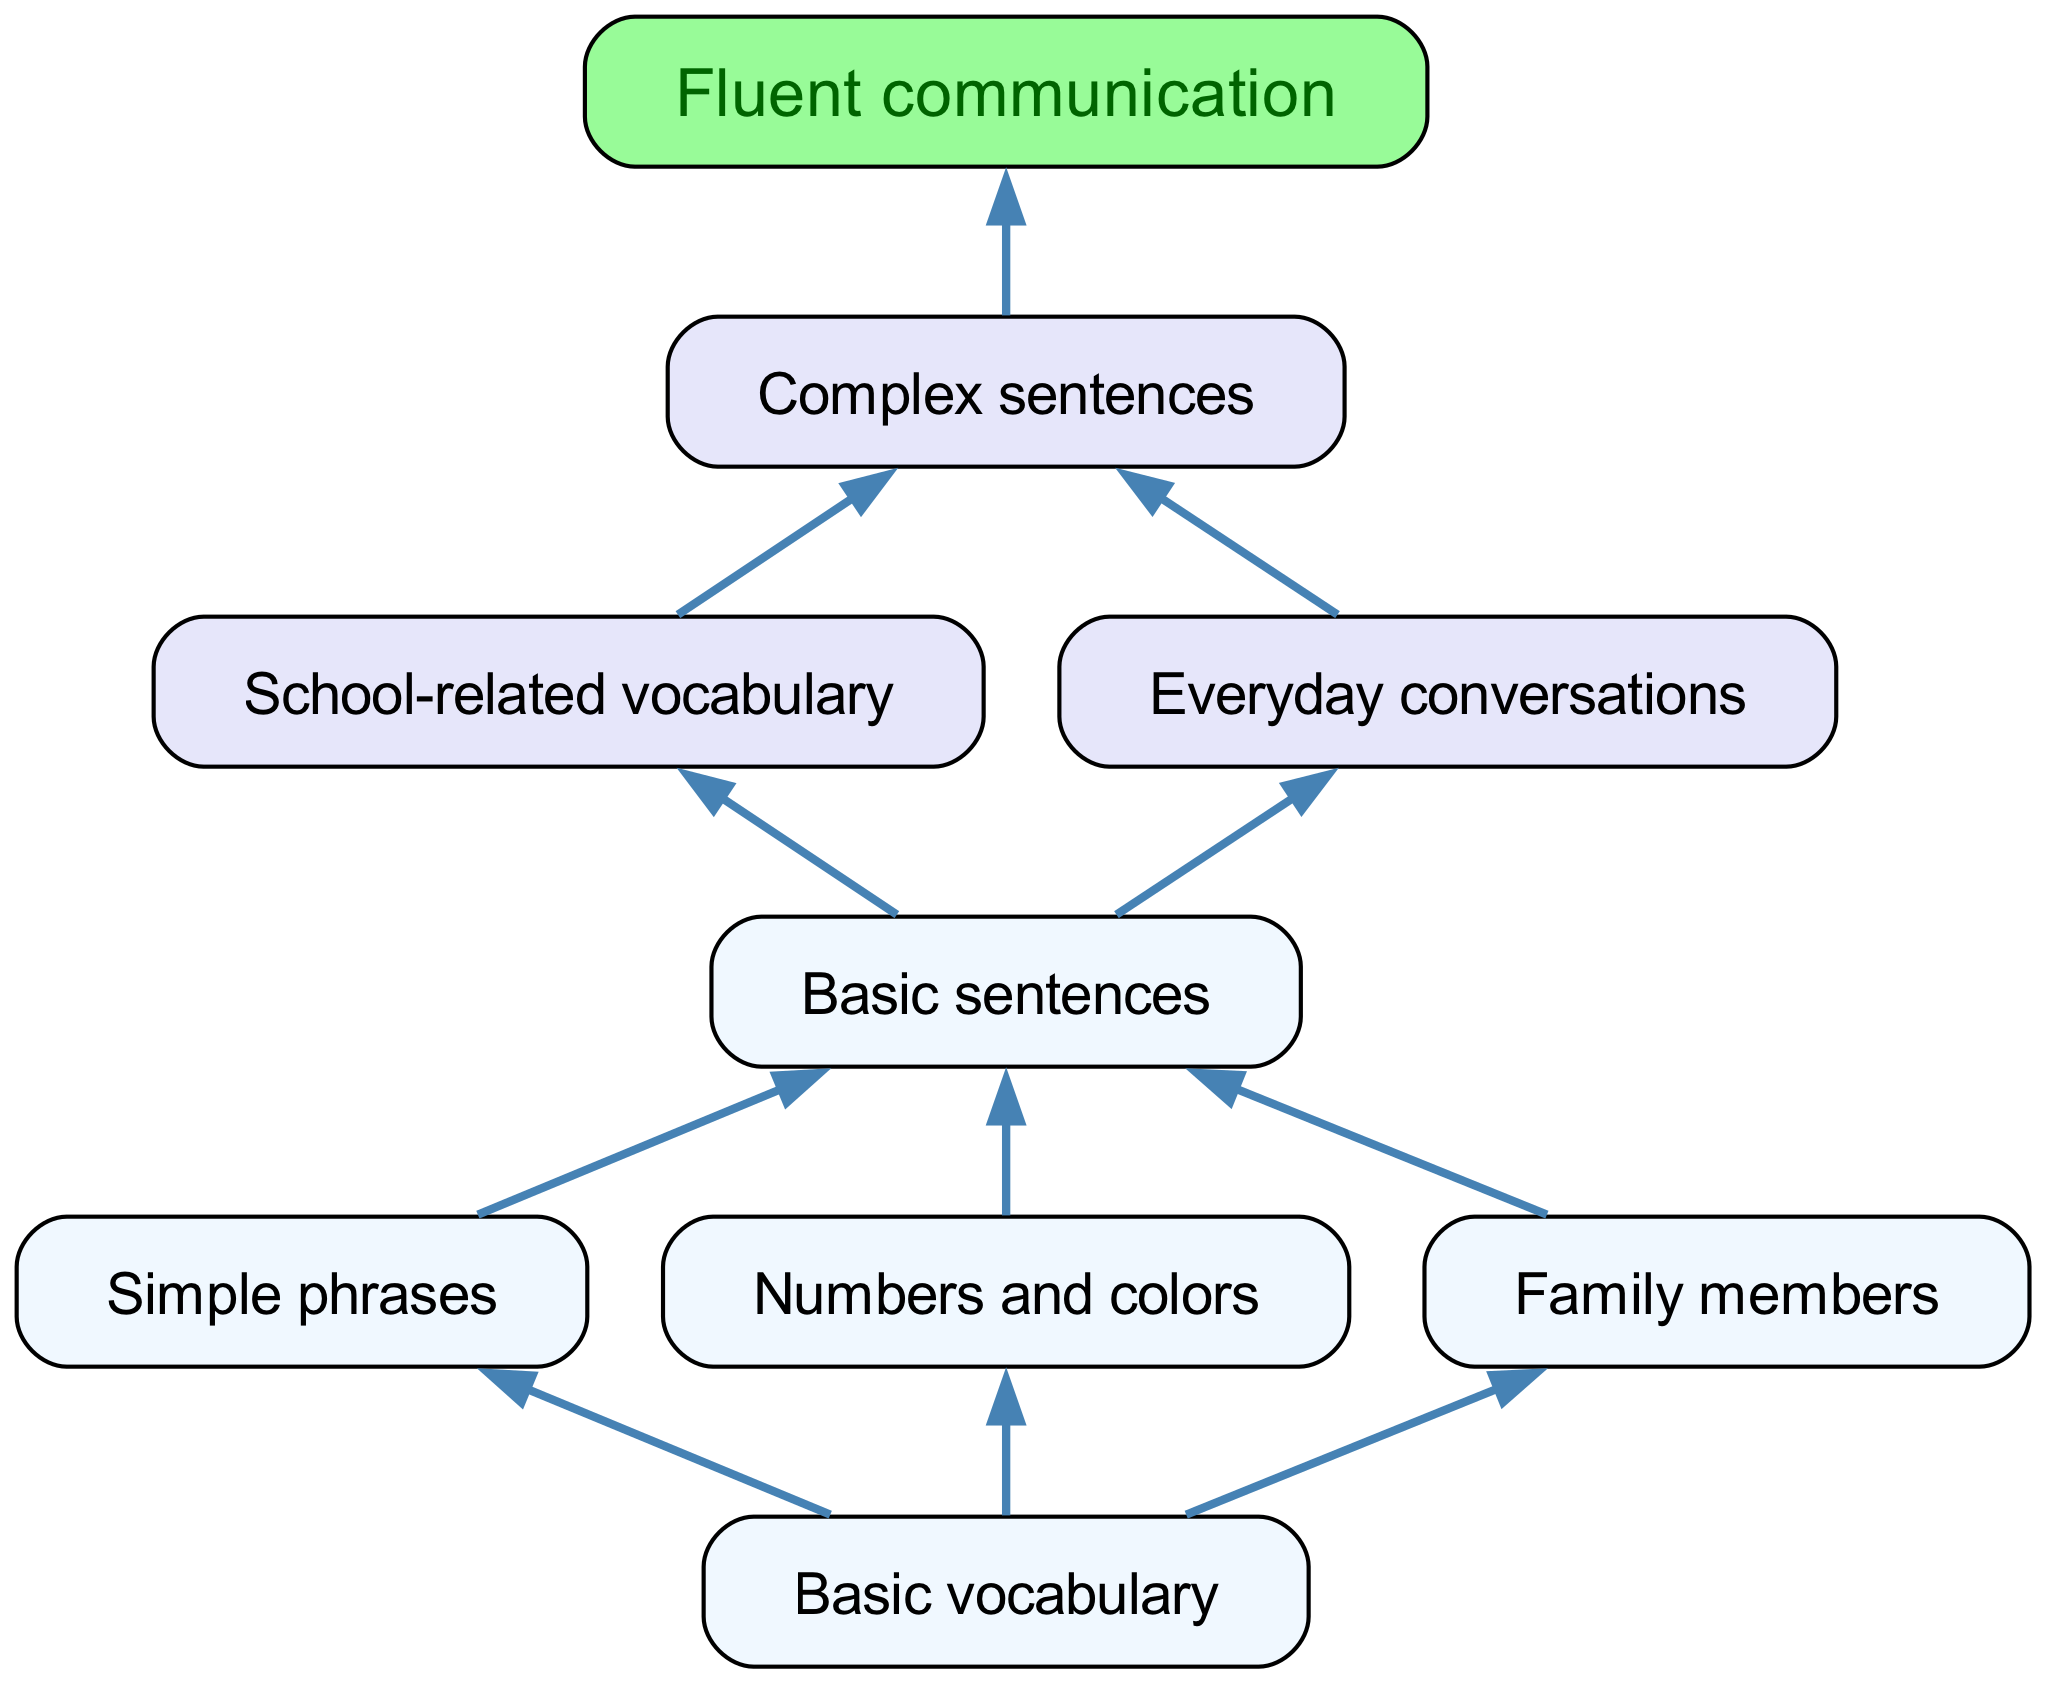What is the top node in the diagram? The top node in the diagram represents the starting point of the learning process, which is "Basic vocabulary."
Answer: Basic vocabulary How many children does "Basic vocabulary" have? The "Basic vocabulary" node has three children: "Simple phrases," "Numbers and colors," and "Family members." Therefore, it has a total of three children nodes.
Answer: 3 What is the final stage in the learning process? The final stage in the learning process is represented by the node "Fluent communication," which indicates the ultimate goal of learning English as a second language.
Answer: Fluent communication Which node connects to both "School-related vocabulary" and "Everyday conversations"? The node that connects to both "School-related vocabulary" and "Everyday conversations" is "Basic sentences," as it is the parent of both these nodes in the flow chart.
Answer: Basic sentences What comes after "Basic sentences" in the learning process? After "Basic sentences," the next step in the process of learning is "Complex sentences," which builds on the foundational knowledge acquired previously.
Answer: Complex sentences How many levels are there in the learning process from the basic to the complex? Starting from "Basic vocabulary" at the first level to "Fluent communication" at the last level, there are a total of five levels in the learning process.
Answer: 5 What are the three areas indicated after "Basic vocabulary"? The three areas indicated after "Basic vocabulary" include "Simple phrases," "Numbers and colors," and "Family members." These areas expand the understanding of basic vocabulary.
Answer: Simple phrases, Numbers and colors, Family members Which node leads directly to "Fluent communication"? The node that leads directly to "Fluent communication" is "Complex sentences," as it is the last step before achieving fluent communication.
Answer: Complex sentences What type of vocabulary is included in the node “School-related vocabulary”? The node "School-related vocabulary" encompasses vocabulary specifically related to academic subjects and school life, which is necessary for effective learning in an educational context.
Answer: Academic vocabulary 